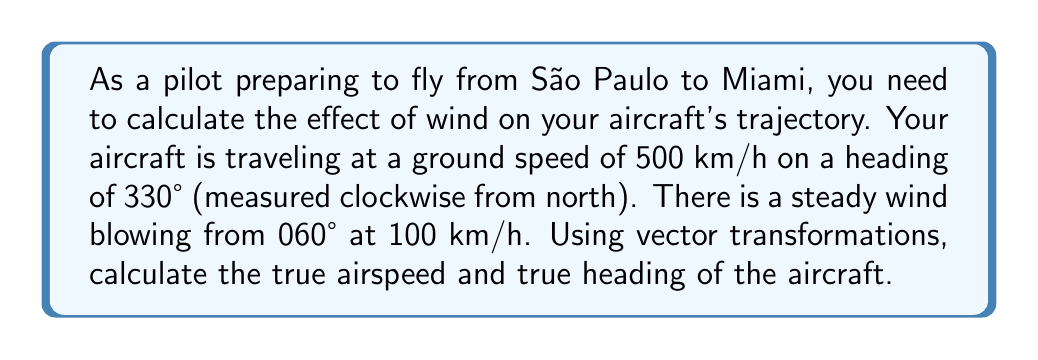Show me your answer to this math problem. To solve this problem, we'll use vector transformations to account for the wind's effect on the aircraft's trajectory. Let's break it down step-by-step:

1) First, let's define our vectors:
   - Ground velocity vector: $\vec{v}_g$
   - Wind velocity vector: $\vec{v}_w$
   - True airspeed vector: $\vec{v}_a$

2) We know that: $\vec{v}_g = \vec{v}_a + \vec{v}_w$

3) Let's break down the ground velocity vector:
   $\vec{v}_g = 500 \cdot (\cos 330°, \sin 330°) = (433.01, -250)$ km/h

4) For the wind vector, we need to reverse its direction (as it's given as the direction the wind is coming from):
   $\vec{v}_w = -100 \cdot (\cos 60°, \sin 60°) = (-50, -86.60)$ km/h

5) Now we can find the true airspeed vector:
   $\vec{v}_a = \vec{v}_g - \vec{v}_w = (433.01, -250) - (-50, -86.60) = (483.01, -163.40)$ km/h

6) To find the true airspeed magnitude:
   $|\vec{v}_a| = \sqrt{483.01^2 + (-163.40)^2} = 510.22$ km/h

7) To find the true heading, we need to calculate the angle of $\vec{v}_a$:
   $\theta = \arctan2(-163.40, 483.01) = -18.69°$

8) Convert this to a heading (clockwise from north):
   True heading = $360° - 18.69° = 341.31°$

[asy]
import geometry;

unitsize(1cm);

draw((-1,0)--(5,0),arrow=Arrow(TeXHead));
draw((0,-1)--(0,5),arrow=Arrow(TeXHead));

draw((0,0)--(3,-1.73),blue,arrow=Arrow(TeXHead));
draw((3,-1.73)--(3.33,-0.57),red,arrow=Arrow(TeXHead));
draw((0,0)--(3.33,-0.57),green,arrow=Arrow(TeXHead));

label("N", (0,5), N);
label("E", (5,0), E);
label("$\vec{v}_g$", (1.5,-0.87), SW, blue);
label("$\vec{v}_w$", (3.17,-1.15), SE, red);
label("$\vec{v}_a$", (1.67,-0.28), NW, green);

[/asy]
Answer: The true airspeed is 510.22 km/h, and the true heading is 341.31°. 